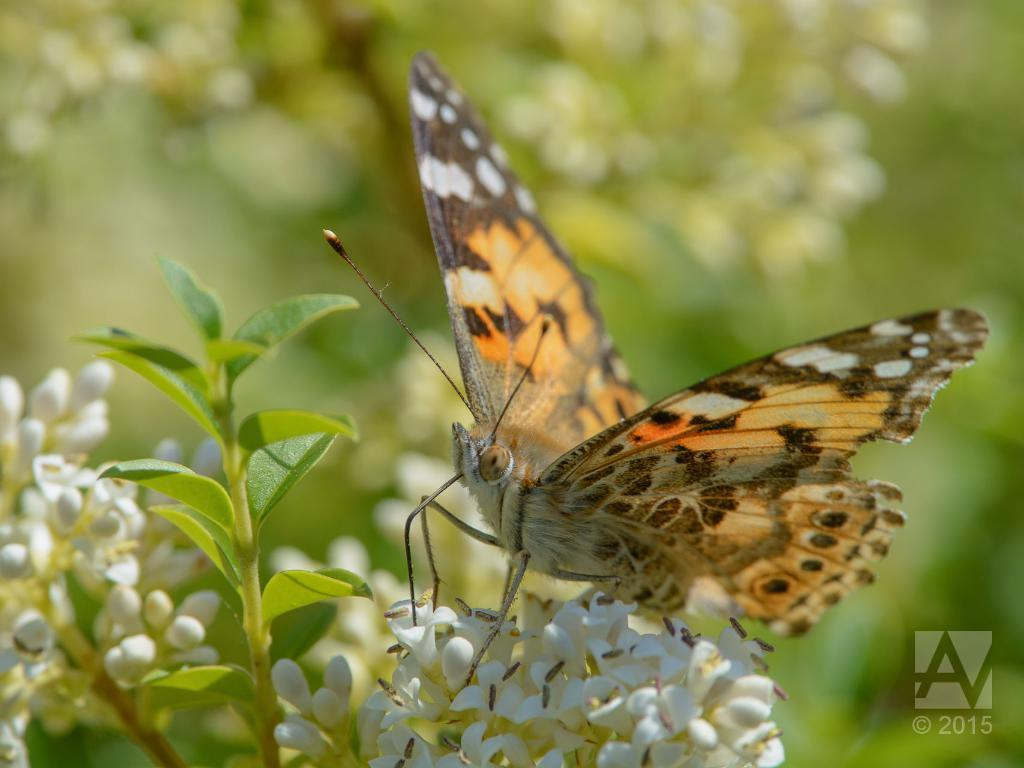What type of insect is present in the image? There is a butterfly in the image. Can you describe the colors of the butterfly? The butterfly has brown, black, white, and orange colors. What type of flowers can be seen in the image? There are white color flowers in the image. What color is the background of the image? The background of the image is green. What religious symbols can be seen in the downtown area in the image? There is no downtown area or religious symbols present in the image; it features a butterfly and flowers against a green background. 